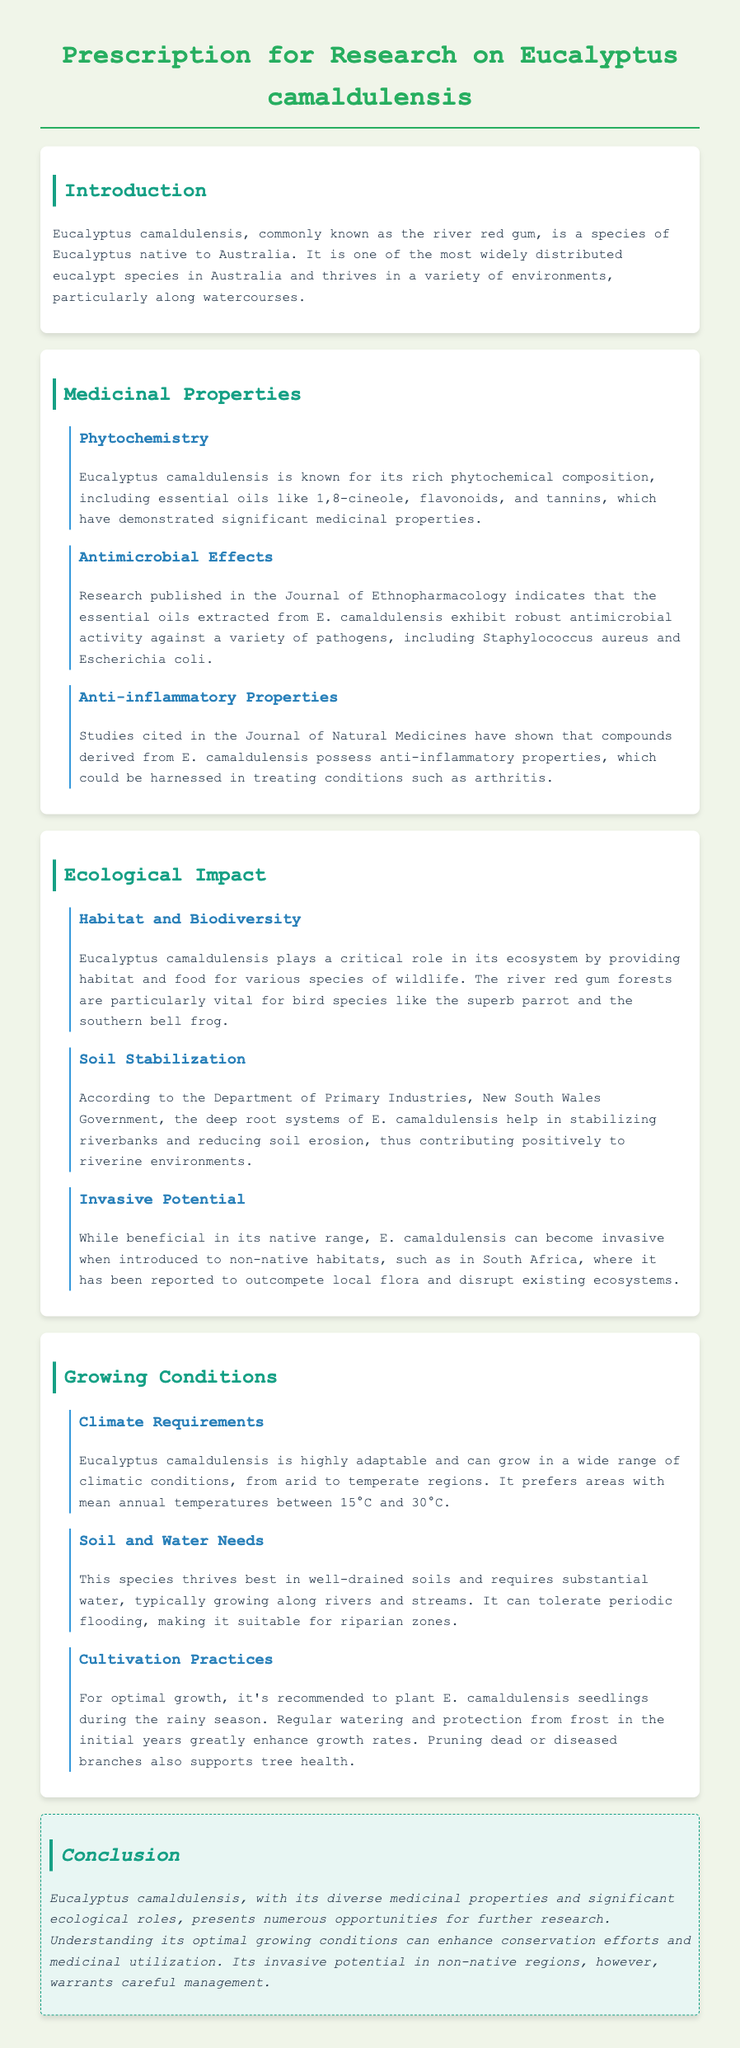What is the common name of Eucalyptus camaldulensis? The common name of Eucalyptus camaldulensis mentioned in the document is "river red gum."
Answer: river red gum What essential oil component exhibits antimicrobial activity? The document mentions that 1,8-cineole is a significant essential oil component with antimicrobial activity.
Answer: 1,8-cineole Which bird species is dependent on Eucalyptus camaldulensis forests? The document states that the superb parrot is one of the bird species that relies on these forests.
Answer: superb parrot What is the preferred mean annual temperature range for Eucalyptus camaldulensis? The optimal mean annual temperature range for this species is between 15°C and 30°C.
Answer: 15°C and 30°C What are the effects of Eucalyptus camaldulensis on riverbanks? The document indicates that the deep root systems help stabilize riverbanks and reduce soil erosion.
Answer: stabilize riverbanks In which regions can Eucalyptus camaldulensis become invasive? The document specifies that it can become invasive in regions like South Africa.
Answer: South Africa What season is recommended for planting Eucalyptus camaldulensis seedlings? The document suggests planting seedlings during the rainy season for optimal growth.
Answer: rainy season What type of document is the provided content? The document presents research guidance specifically for studying Eucalyptus camaldulensis.
Answer: research guidance 